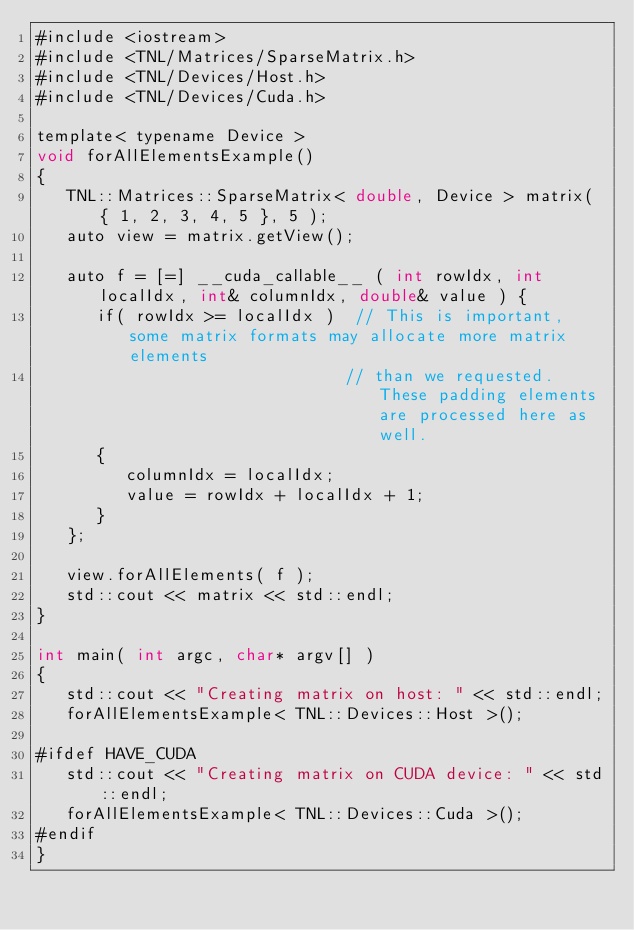<code> <loc_0><loc_0><loc_500><loc_500><_Cuda_>#include <iostream>
#include <TNL/Matrices/SparseMatrix.h>
#include <TNL/Devices/Host.h>
#include <TNL/Devices/Cuda.h>

template< typename Device >
void forAllElementsExample()
{
   TNL::Matrices::SparseMatrix< double, Device > matrix( { 1, 2, 3, 4, 5 }, 5 );
   auto view = matrix.getView();

   auto f = [=] __cuda_callable__ ( int rowIdx, int localIdx, int& columnIdx, double& value ) {
      if( rowIdx >= localIdx )  // This is important, some matrix formats may allocate more matrix elements
                               // than we requested. These padding elements are processed here as well.
      {
         columnIdx = localIdx;
         value = rowIdx + localIdx + 1;
      }
   };

   view.forAllElements( f );
   std::cout << matrix << std::endl;
}

int main( int argc, char* argv[] )
{
   std::cout << "Creating matrix on host: " << std::endl;
   forAllElementsExample< TNL::Devices::Host >();

#ifdef HAVE_CUDA
   std::cout << "Creating matrix on CUDA device: " << std::endl;
   forAllElementsExample< TNL::Devices::Cuda >();
#endif
}
</code> 